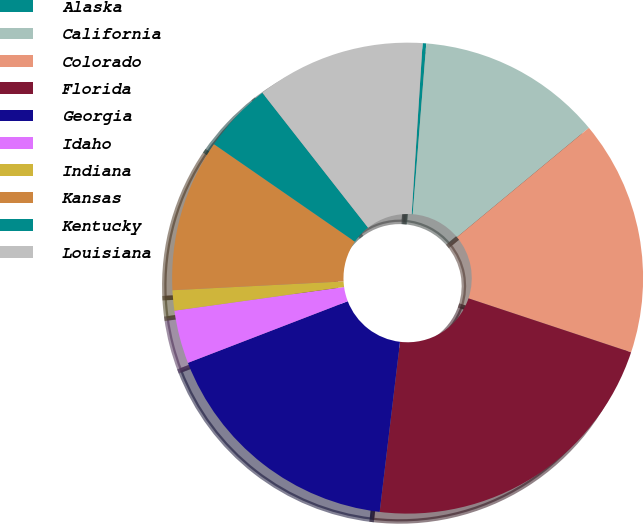Convert chart to OTSL. <chart><loc_0><loc_0><loc_500><loc_500><pie_chart><fcel>Alaska<fcel>California<fcel>Colorado<fcel>Florida<fcel>Georgia<fcel>Idaho<fcel>Indiana<fcel>Kansas<fcel>Kentucky<fcel>Louisiana<nl><fcel>0.25%<fcel>12.72%<fcel>16.12%<fcel>21.79%<fcel>17.25%<fcel>3.65%<fcel>1.39%<fcel>10.45%<fcel>4.79%<fcel>11.59%<nl></chart> 